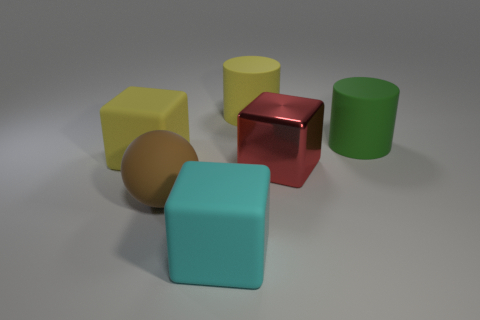Subtract all big yellow rubber cubes. How many cubes are left? 2 Subtract all yellow blocks. How many blocks are left? 2 Subtract all cylinders. How many objects are left? 4 Add 1 small blue matte blocks. How many objects exist? 7 Subtract all yellow cubes. How many yellow cylinders are left? 1 Subtract all balls. Subtract all red metallic blocks. How many objects are left? 4 Add 2 big brown rubber spheres. How many big brown rubber spheres are left? 3 Add 1 large metallic objects. How many large metallic objects exist? 2 Subtract 0 gray cubes. How many objects are left? 6 Subtract all gray cylinders. Subtract all brown spheres. How many cylinders are left? 2 